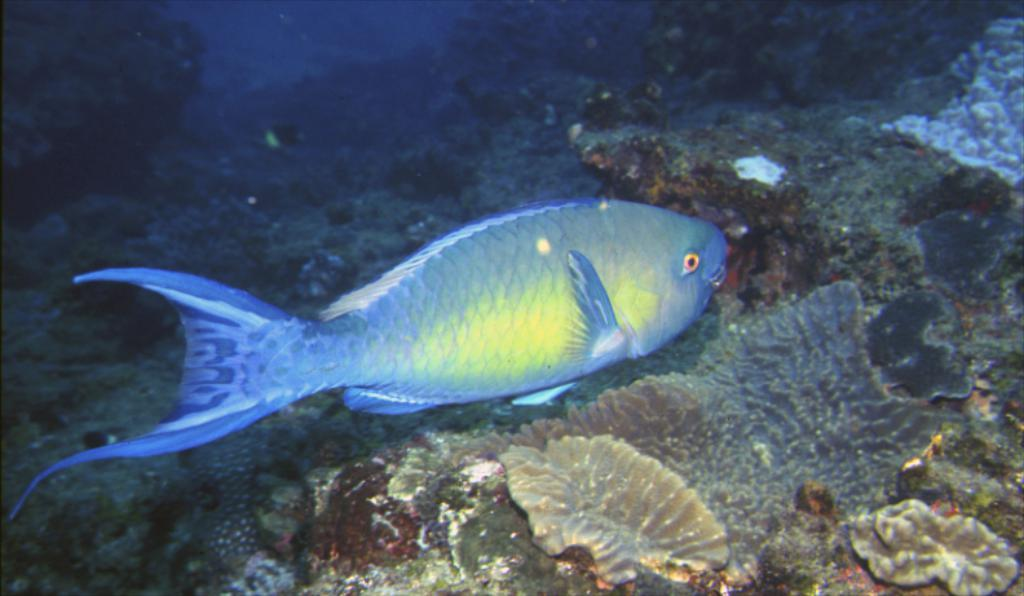What type of animal is in the image? There is a fish in the image. Where is the fish located? The fish is in the water. What year is depicted in the image? There is no specific year depicted in the image, as it only features a fish in the water. 